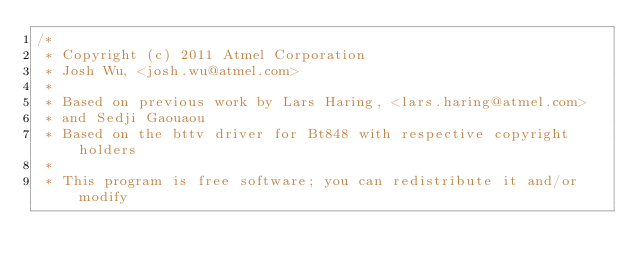<code> <loc_0><loc_0><loc_500><loc_500><_C_>/*
 * Copyright (c) 2011 Atmel Corporation
 * Josh Wu, <josh.wu@atmel.com>
 *
 * Based on previous work by Lars Haring, <lars.haring@atmel.com>
 * and Sedji Gaouaou
 * Based on the bttv driver for Bt848 with respective copyright holders
 *
 * This program is free software; you can redistribute it and/or modify</code> 